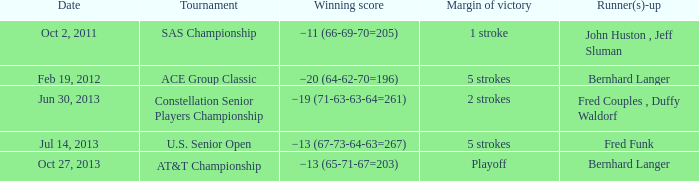Who's the Runner(s)-up with a Winning score of −19 (71-63-63-64=261)? Fred Couples , Duffy Waldorf. 